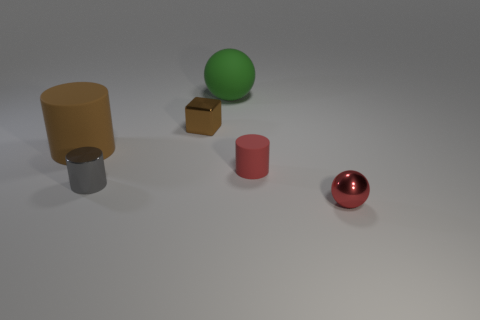Add 1 big matte objects. How many objects exist? 7 Subtract all small cylinders. How many cylinders are left? 1 Subtract all cubes. How many objects are left? 5 Add 6 green rubber balls. How many green rubber balls are left? 7 Add 4 big green objects. How many big green objects exist? 5 Subtract 0 cyan cylinders. How many objects are left? 6 Subtract all purple cylinders. Subtract all brown blocks. How many cylinders are left? 3 Subtract all purple rubber cylinders. Subtract all tiny brown blocks. How many objects are left? 5 